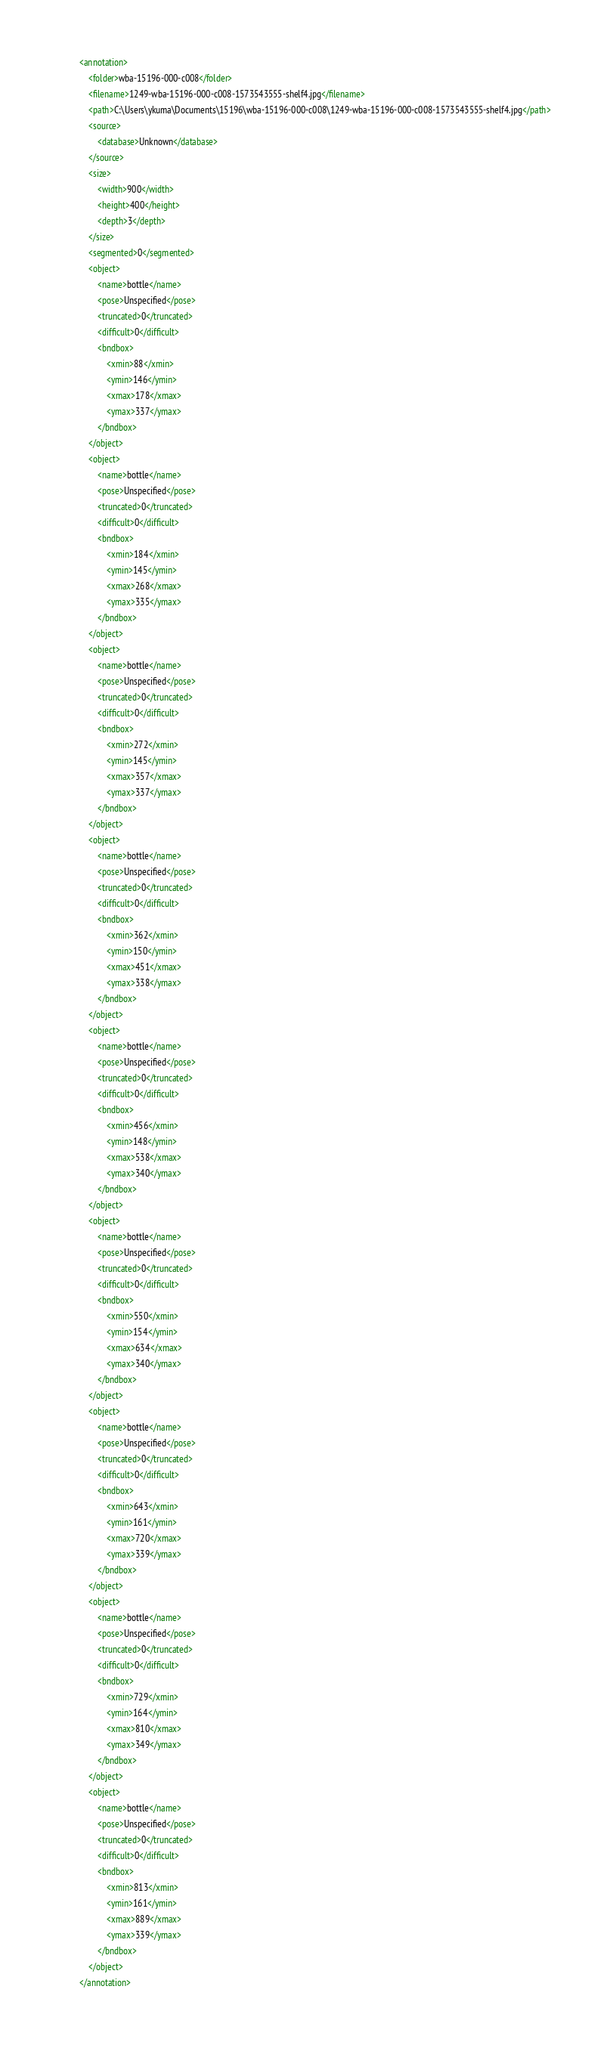<code> <loc_0><loc_0><loc_500><loc_500><_XML_><annotation>
	<folder>wba-15196-000-c008</folder>
	<filename>1249-wba-15196-000-c008-1573543555-shelf4.jpg</filename>
	<path>C:\Users\ykuma\Documents\15196\wba-15196-000-c008\1249-wba-15196-000-c008-1573543555-shelf4.jpg</path>
	<source>
		<database>Unknown</database>
	</source>
	<size>
		<width>900</width>
		<height>400</height>
		<depth>3</depth>
	</size>
	<segmented>0</segmented>
	<object>
		<name>bottle</name>
		<pose>Unspecified</pose>
		<truncated>0</truncated>
		<difficult>0</difficult>
		<bndbox>
			<xmin>88</xmin>
			<ymin>146</ymin>
			<xmax>178</xmax>
			<ymax>337</ymax>
		</bndbox>
	</object>
	<object>
		<name>bottle</name>
		<pose>Unspecified</pose>
		<truncated>0</truncated>
		<difficult>0</difficult>
		<bndbox>
			<xmin>184</xmin>
			<ymin>145</ymin>
			<xmax>268</xmax>
			<ymax>335</ymax>
		</bndbox>
	</object>
	<object>
		<name>bottle</name>
		<pose>Unspecified</pose>
		<truncated>0</truncated>
		<difficult>0</difficult>
		<bndbox>
			<xmin>272</xmin>
			<ymin>145</ymin>
			<xmax>357</xmax>
			<ymax>337</ymax>
		</bndbox>
	</object>
	<object>
		<name>bottle</name>
		<pose>Unspecified</pose>
		<truncated>0</truncated>
		<difficult>0</difficult>
		<bndbox>
			<xmin>362</xmin>
			<ymin>150</ymin>
			<xmax>451</xmax>
			<ymax>338</ymax>
		</bndbox>
	</object>
	<object>
		<name>bottle</name>
		<pose>Unspecified</pose>
		<truncated>0</truncated>
		<difficult>0</difficult>
		<bndbox>
			<xmin>456</xmin>
			<ymin>148</ymin>
			<xmax>538</xmax>
			<ymax>340</ymax>
		</bndbox>
	</object>
	<object>
		<name>bottle</name>
		<pose>Unspecified</pose>
		<truncated>0</truncated>
		<difficult>0</difficult>
		<bndbox>
			<xmin>550</xmin>
			<ymin>154</ymin>
			<xmax>634</xmax>
			<ymax>340</ymax>
		</bndbox>
	</object>
	<object>
		<name>bottle</name>
		<pose>Unspecified</pose>
		<truncated>0</truncated>
		<difficult>0</difficult>
		<bndbox>
			<xmin>643</xmin>
			<ymin>161</ymin>
			<xmax>720</xmax>
			<ymax>339</ymax>
		</bndbox>
	</object>
	<object>
		<name>bottle</name>
		<pose>Unspecified</pose>
		<truncated>0</truncated>
		<difficult>0</difficult>
		<bndbox>
			<xmin>729</xmin>
			<ymin>164</ymin>
			<xmax>810</xmax>
			<ymax>349</ymax>
		</bndbox>
	</object>
	<object>
		<name>bottle</name>
		<pose>Unspecified</pose>
		<truncated>0</truncated>
		<difficult>0</difficult>
		<bndbox>
			<xmin>813</xmin>
			<ymin>161</ymin>
			<xmax>889</xmax>
			<ymax>339</ymax>
		</bndbox>
	</object>
</annotation></code> 